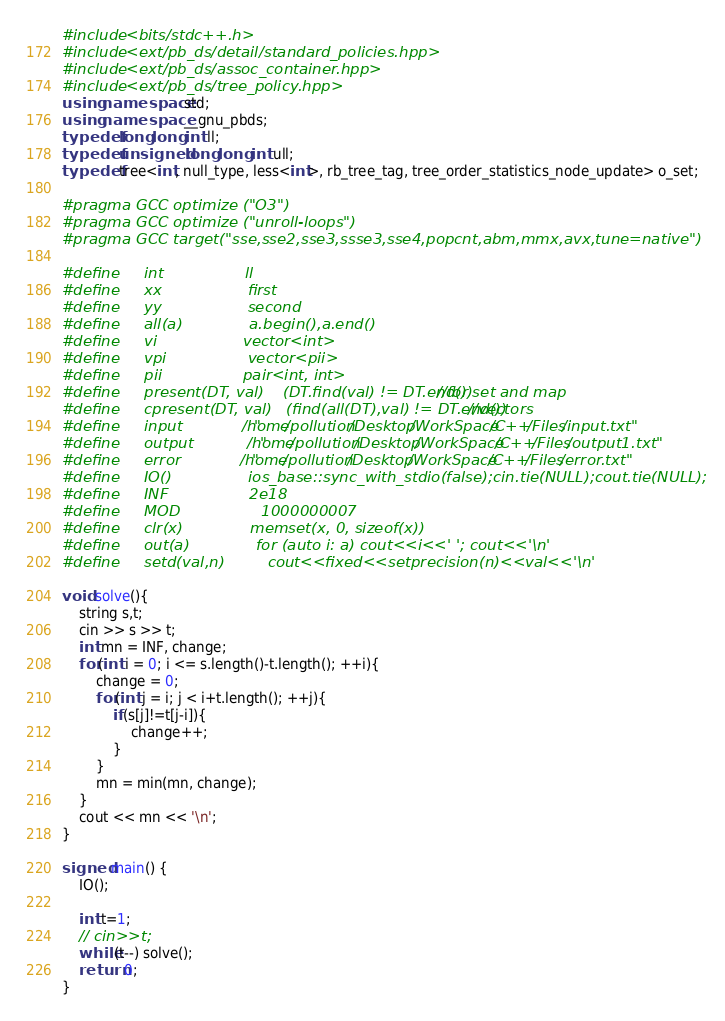Convert code to text. <code><loc_0><loc_0><loc_500><loc_500><_C++_>#include <bits/stdc++.h>
#include <ext/pb_ds/detail/standard_policies.hpp>
#include <ext/pb_ds/assoc_container.hpp>
#include <ext/pb_ds/tree_policy.hpp>
using namespace std;
using namespace __gnu_pbds;
typedef long long int ll;
typedef unsigned long long int ull;
typedef tree<int, null_type, less<int>, rb_tree_tag, tree_order_statistics_node_update> o_set;

#pragma GCC optimize ("O3")
#pragma GCC optimize ("unroll-loops")
#pragma GCC target("sse,sse2,sse3,ssse3,sse4,popcnt,abm,mmx,avx,tune=native")

#define     int                 ll
#define     xx                  first
#define     yy                  second    
#define     all(a)              a.begin(),a.end()
#define     vi                  vector<int>
#define     vpi                 vector<pii>
#define     pii                 pair<int, int>
#define     present(DT, val)    (DT.find(val) != DT.end()) //for set and map
#define     cpresent(DT, val)   (find(all(DT),val) != DT.end()) //vectors
#define     input               "/home/pollution/Desktop/WorkSpace/C++/Files/input.txt"
#define     output              "/home/pollution/Desktop/WorkSpace/C++/Files/output1.txt"
#define     error               "/home/pollution/Desktop/WorkSpace/C++/Files/error.txt"
#define     IO()                ios_base::sync_with_stdio(false);cin.tie(NULL);cout.tie(NULL);
#define     INF                 2e18
#define     MOD                 1000000007
#define     clr(x)              memset(x, 0, sizeof(x))
#define     out(a)              for (auto i: a) cout<<i<<' '; cout<<'\n'
#define     setd(val,n)         cout<<fixed<<setprecision(n)<<val<<'\n'

void solve(){
    string s,t;
    cin >> s >> t;
    int mn = INF, change;
    for(int i = 0; i <= s.length()-t.length(); ++i){
    	change = 0;
    	for(int j = i; j < i+t.length(); ++j){
    		if(s[j]!=t[j-i]){
    			change++;
    		}
    	}
    	mn = min(mn, change);
    }
    cout << mn << '\n';
}

signed main() { 
    IO();
    
    int t=1;
    // cin>>t;
    while(t--) solve();
    return 0; 
}</code> 